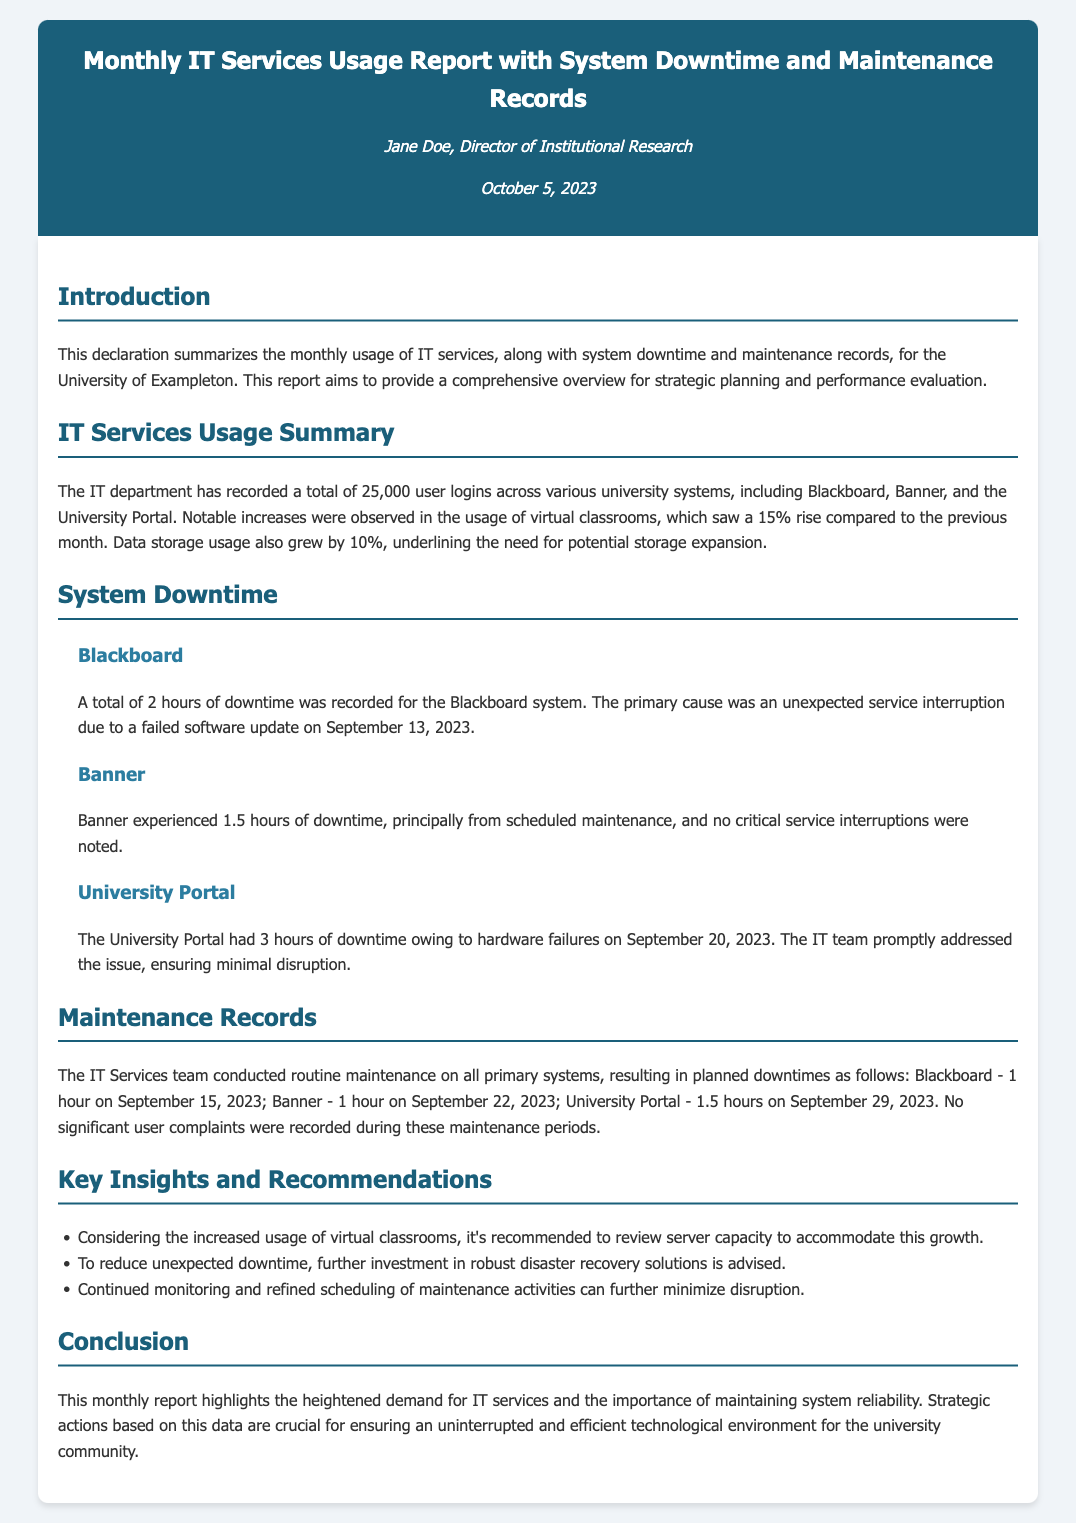What is the total number of user logins? The report states that there were 25,000 user logins across various university systems.
Answer: 25,000 What was the percentage increase in virtual classroom usage? The document notes a 15% rise in the usage of virtual classrooms compared to the previous month.
Answer: 15% How many hours of downtime did Blackboard experience? The report specifies that Blackboard had a total of 2 hours of downtime.
Answer: 2 hours What was the main cause of downtime for the University Portal? The University Portal's downtime was attributed to hardware failures.
Answer: Hardware failures What date did the IT team perform maintenance on Banner? The report indicates that maintenance on Banner was conducted on September 22, 2023.
Answer: September 22, 2023 What is one recommendation based on the report's insights? The report recommends reviewing server capacity to accommodate the growth in virtual classrooms.
Answer: Review server capacity What was the total downtime for the University Portal in hours? The document states that the University Portal had a total of 3 hours of downtime.
Answer: 3 hours Who authored the report? The document lists Jane Doe as the author of the report.
Answer: Jane Doe What is the main purpose of this report? The document aims to provide a comprehensive overview for strategic planning and performance evaluation.
Answer: Strategic planning and performance evaluation 